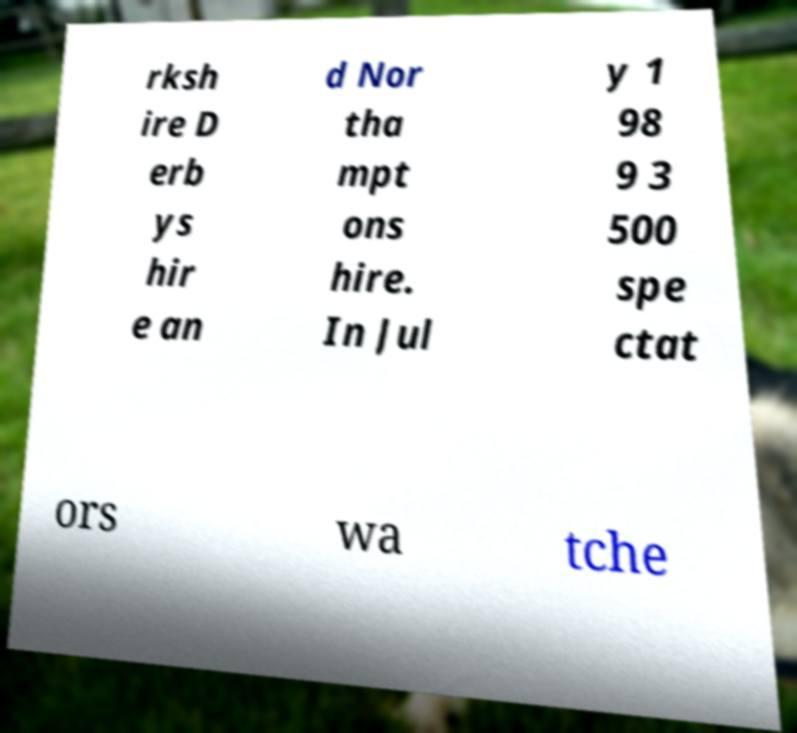Can you accurately transcribe the text from the provided image for me? rksh ire D erb ys hir e an d Nor tha mpt ons hire. In Jul y 1 98 9 3 500 spe ctat ors wa tche 